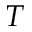<formula> <loc_0><loc_0><loc_500><loc_500>T</formula> 